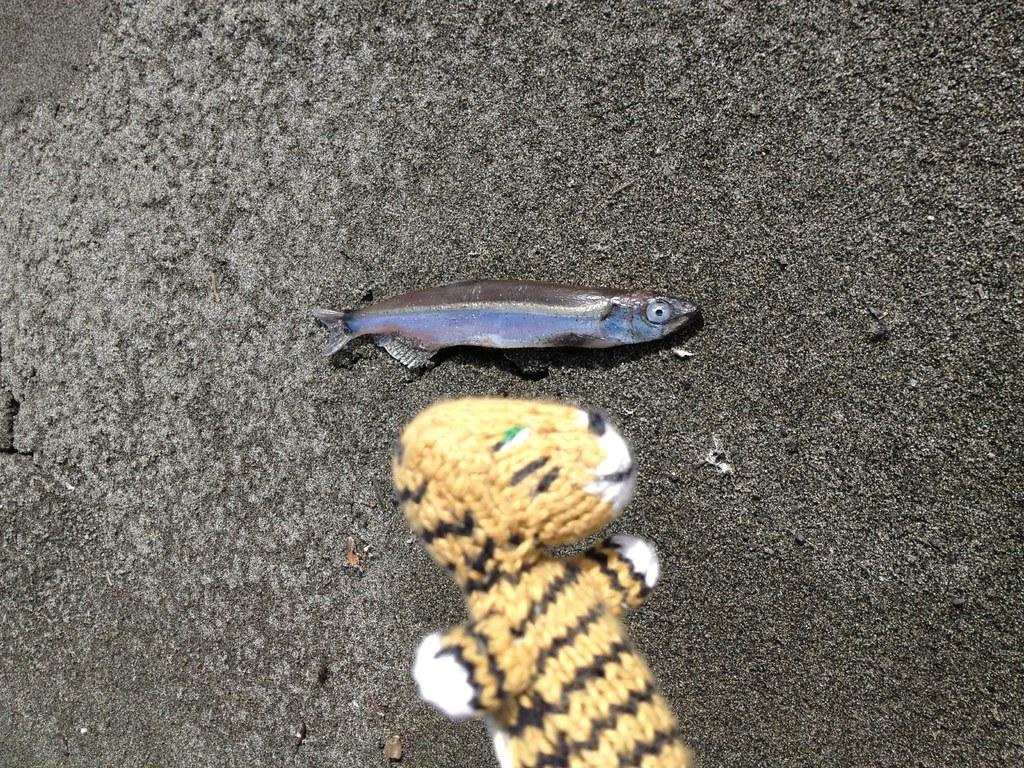What is the main subject in the middle of the picture? There is a black color fish in the middle of the picture. What other object can be seen at the bottom of the picture? There is a toy in yellow and white color at the bottom of the picture. What type of background is visible in the image? There is a road in black color in the background of the picture. What type of joke can be heard coming from the fish in the image? There is no indication of a joke or any sound in the image, as it features a fish and a toy in a still setting. 